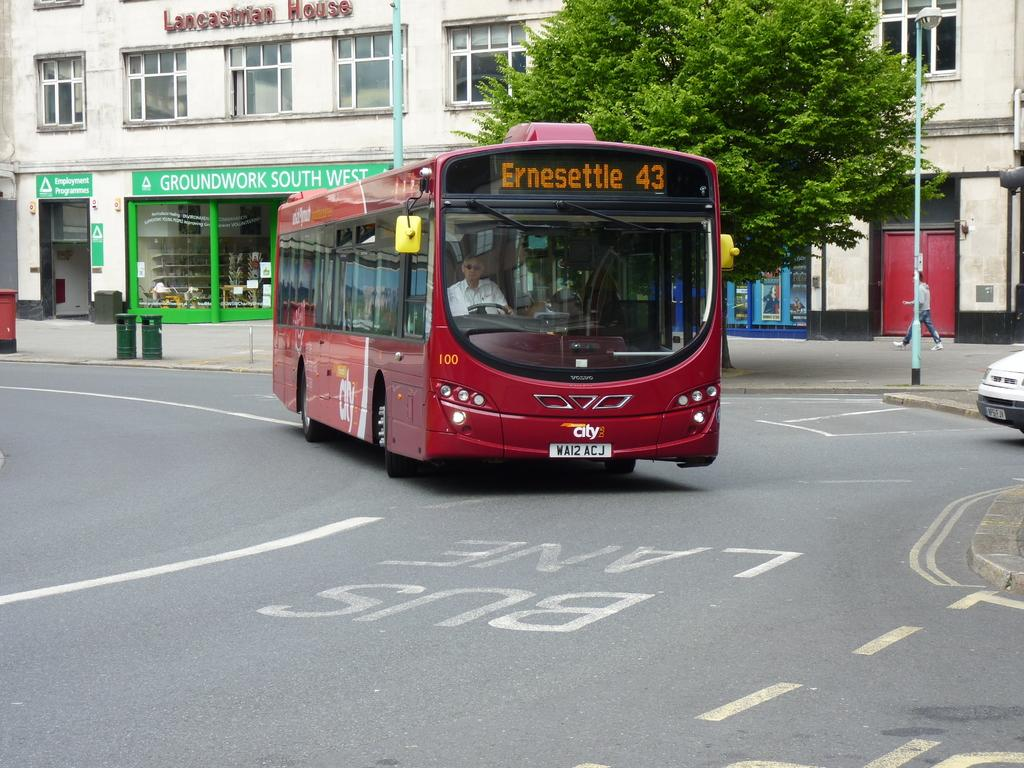What is the main subject of the image? There is a bus in the image. Where is the bus located? The bus is on the road. What can be seen in the background of the image? There is a tree and a building with text in the background of the image. Can you hear the bus laughing in the image? There is no sound or indication of laughter in the image; it is a still image of a bus on the road. 